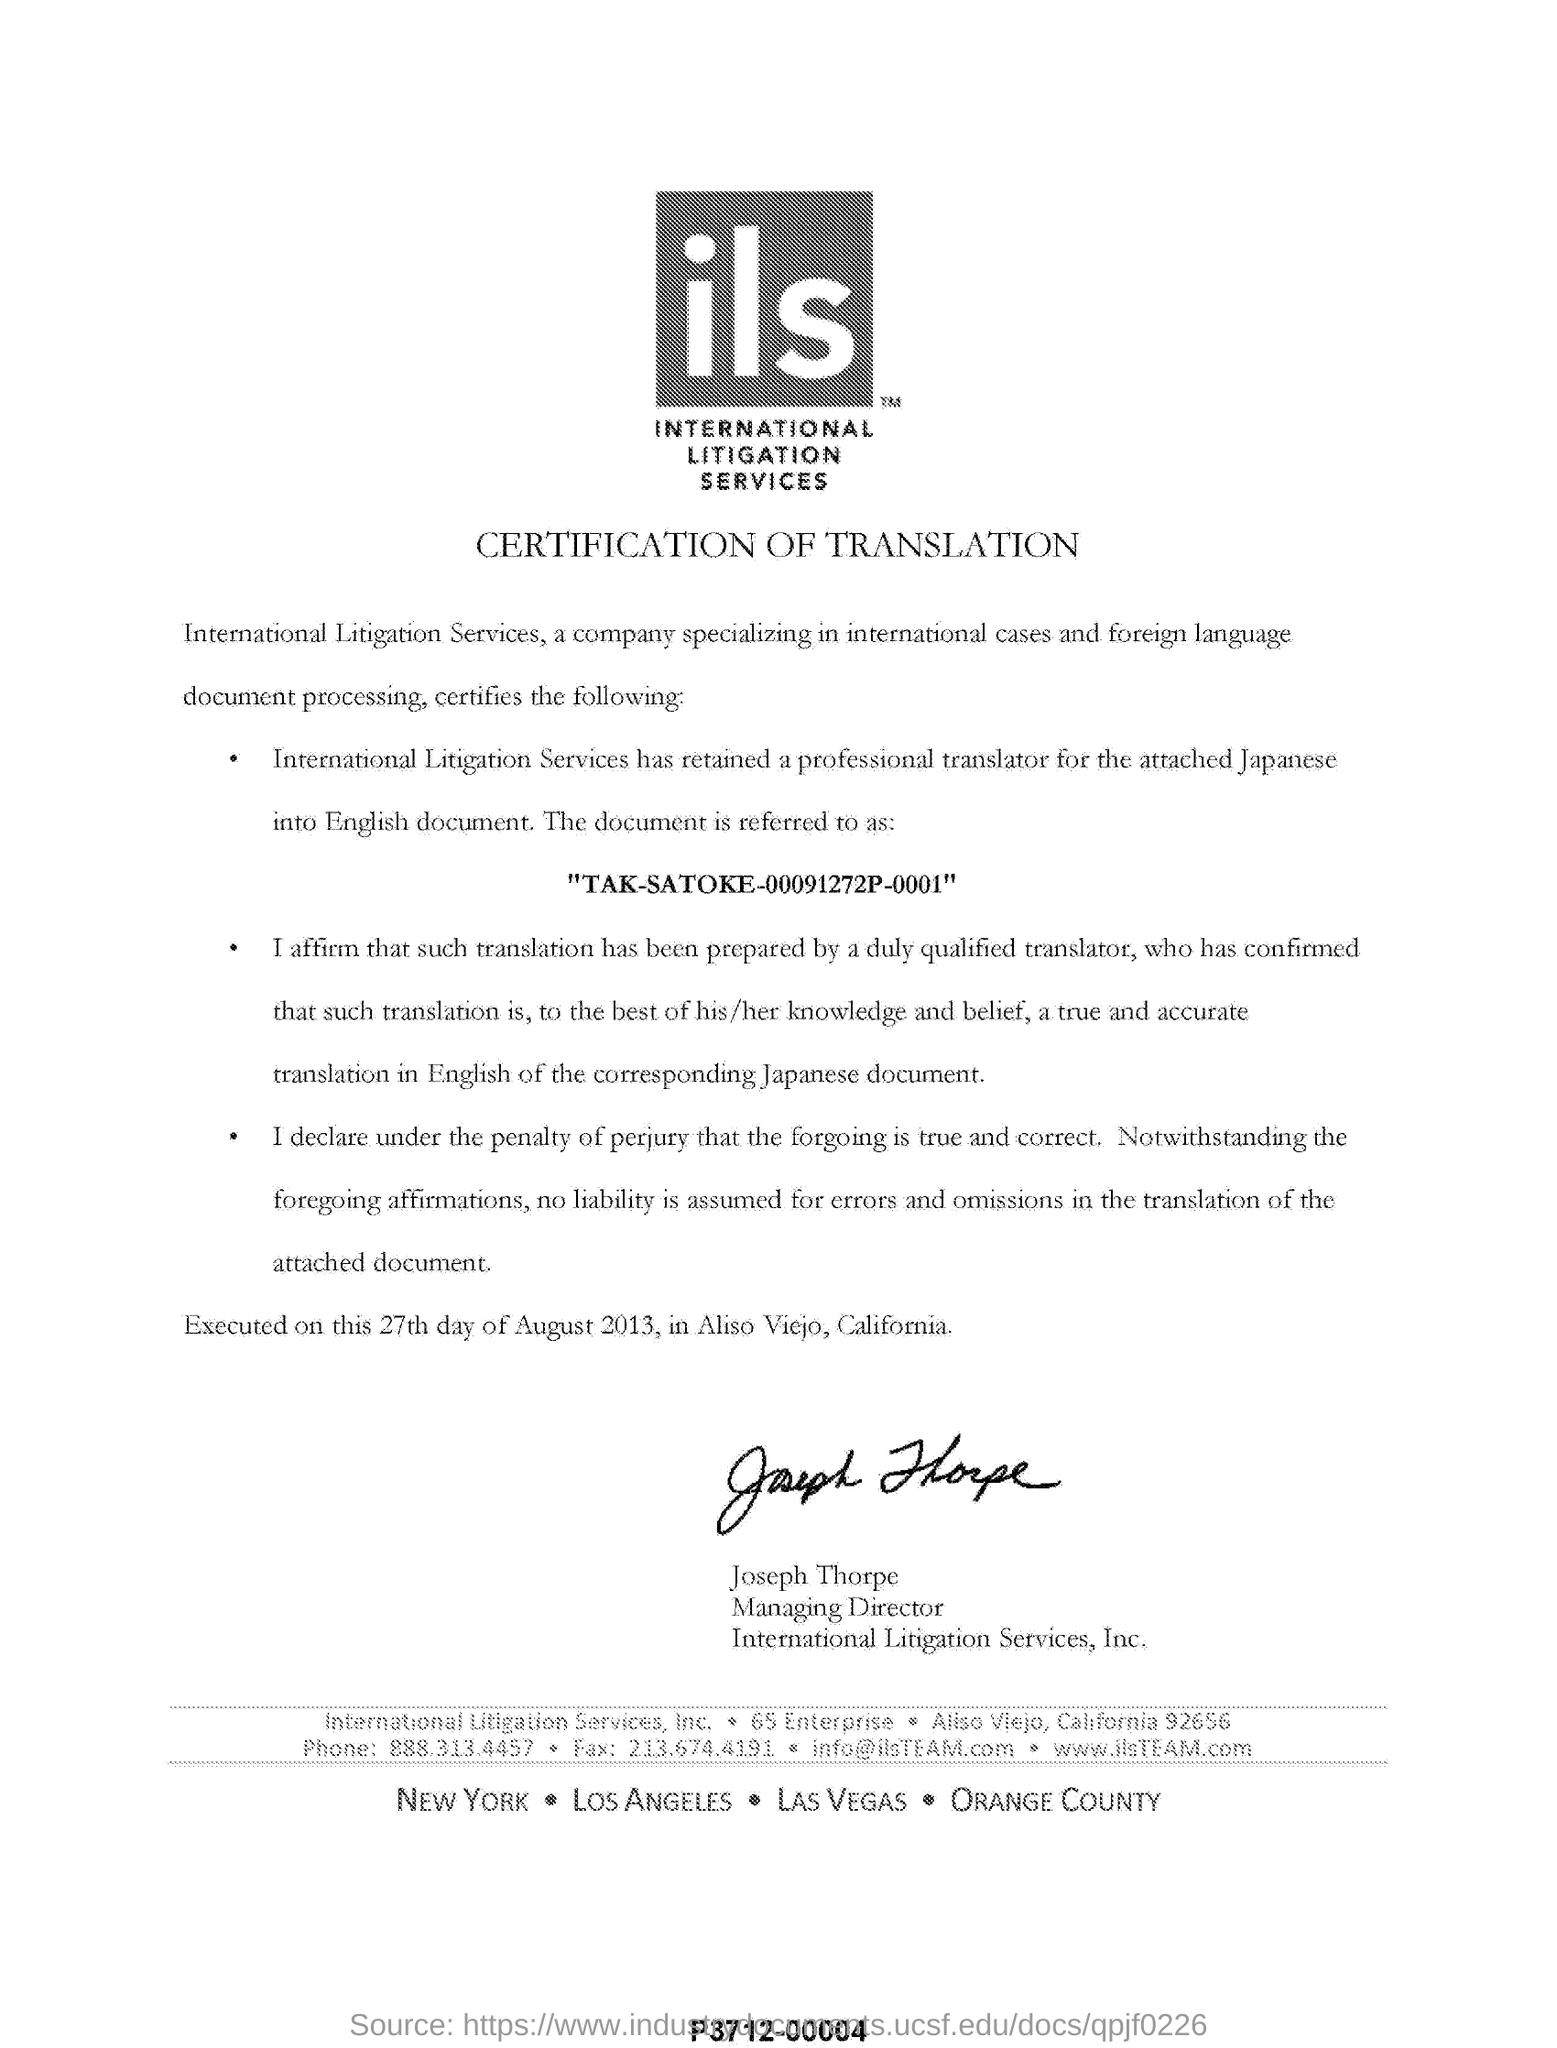What sort of certification is this
Your response must be concise. Certification of Translation. What is the specialization  of international litigation services?
Your answer should be very brief. International cases and foreign language document processing. When is this executed on
Your answer should be compact. 27th day of August 2013. Who is the managing director of international litigation services
Your response must be concise. Joseph Thorpe. 